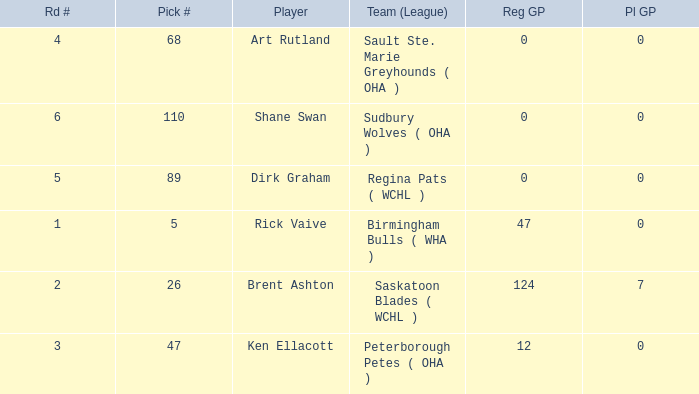How many reg GP for rick vaive in round 1? None. Can you parse all the data within this table? {'header': ['Rd #', 'Pick #', 'Player', 'Team (League)', 'Reg GP', 'Pl GP'], 'rows': [['4', '68', 'Art Rutland', 'Sault Ste. Marie Greyhounds ( OHA )', '0', '0'], ['6', '110', 'Shane Swan', 'Sudbury Wolves ( OHA )', '0', '0'], ['5', '89', 'Dirk Graham', 'Regina Pats ( WCHL )', '0', '0'], ['1', '5', 'Rick Vaive', 'Birmingham Bulls ( WHA )', '47', '0'], ['2', '26', 'Brent Ashton', 'Saskatoon Blades ( WCHL )', '124', '7'], ['3', '47', 'Ken Ellacott', 'Peterborough Petes ( OHA )', '12', '0']]} 